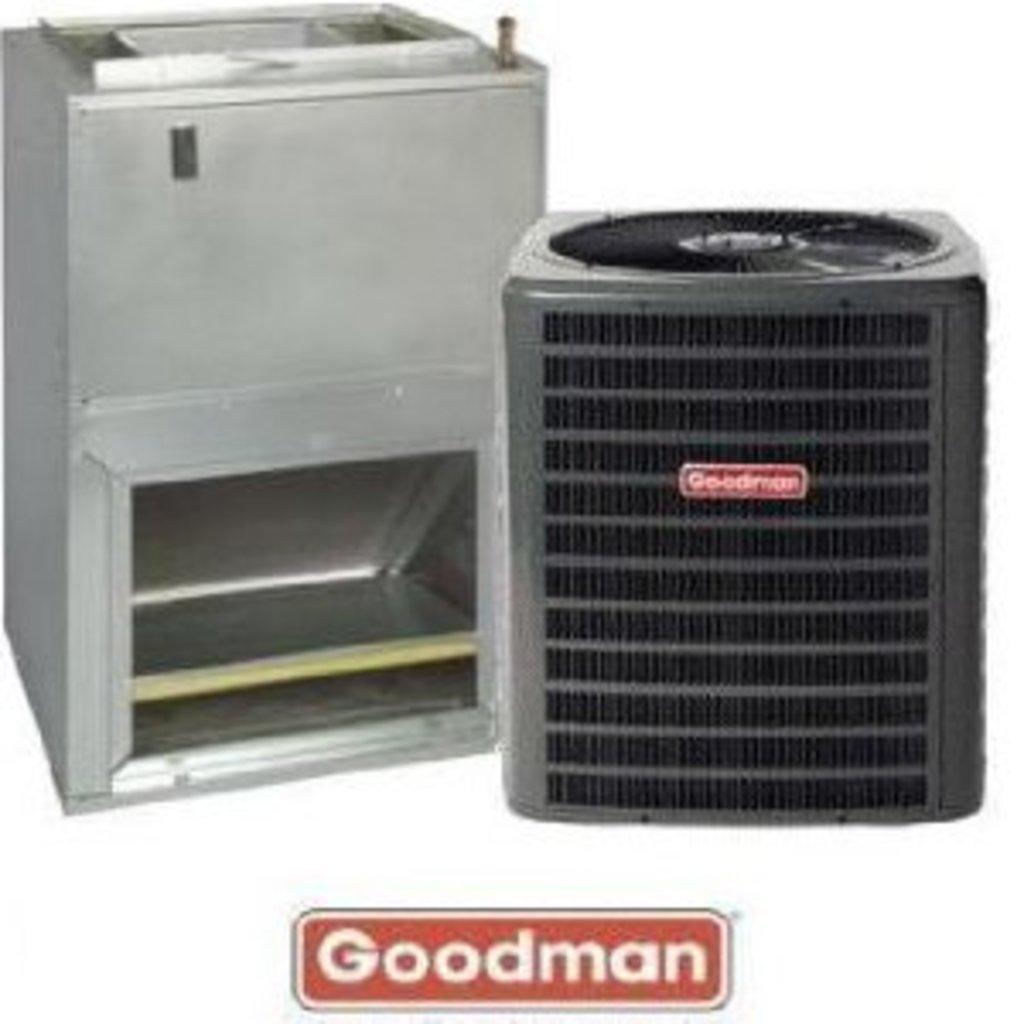That is the make of the above gadgets?
Keep it short and to the point. Goodman. 